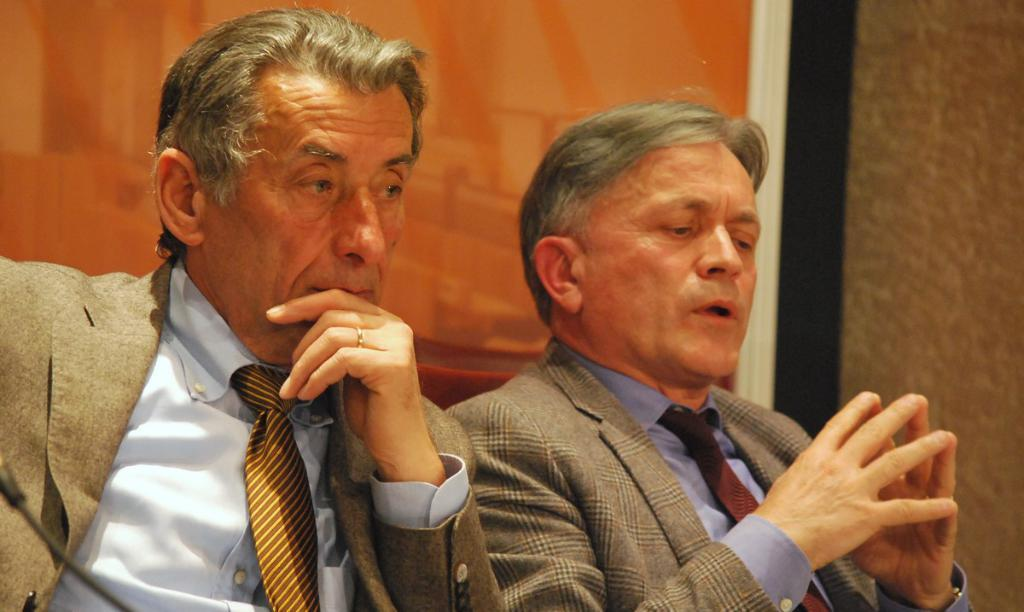How many people are in the image? There are two men in the image. What are the men wearing? The men are wearing suits. What can be seen in the background of the image? There is a wall and a picture frame in the background of the image. Is there any butter visible on the edge of the picture frame in the image? There is no butter present in the image, and therefore it cannot be seen on the edge of the picture frame. 